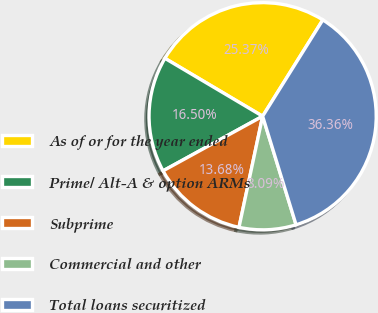<chart> <loc_0><loc_0><loc_500><loc_500><pie_chart><fcel>As of or for the year ended<fcel>Prime/ Alt-A & option ARMs<fcel>Subprime<fcel>Commercial and other<fcel>Total loans securitized<nl><fcel>25.37%<fcel>16.5%<fcel>13.68%<fcel>8.09%<fcel>36.36%<nl></chart> 